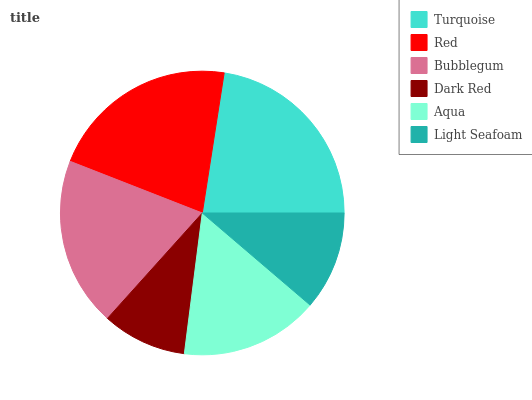Is Dark Red the minimum?
Answer yes or no. Yes. Is Turquoise the maximum?
Answer yes or no. Yes. Is Red the minimum?
Answer yes or no. No. Is Red the maximum?
Answer yes or no. No. Is Turquoise greater than Red?
Answer yes or no. Yes. Is Red less than Turquoise?
Answer yes or no. Yes. Is Red greater than Turquoise?
Answer yes or no. No. Is Turquoise less than Red?
Answer yes or no. No. Is Bubblegum the high median?
Answer yes or no. Yes. Is Aqua the low median?
Answer yes or no. Yes. Is Light Seafoam the high median?
Answer yes or no. No. Is Red the low median?
Answer yes or no. No. 